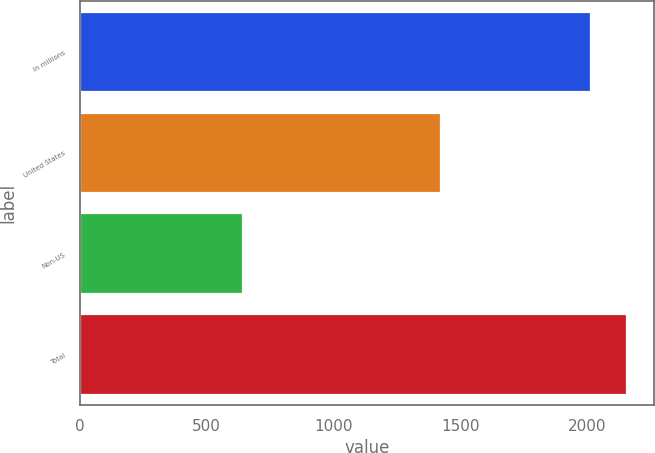Convert chart. <chart><loc_0><loc_0><loc_500><loc_500><bar_chart><fcel>In millions<fcel>United States<fcel>Non-US<fcel>Total<nl><fcel>2015<fcel>1425.1<fcel>643<fcel>2157.51<nl></chart> 